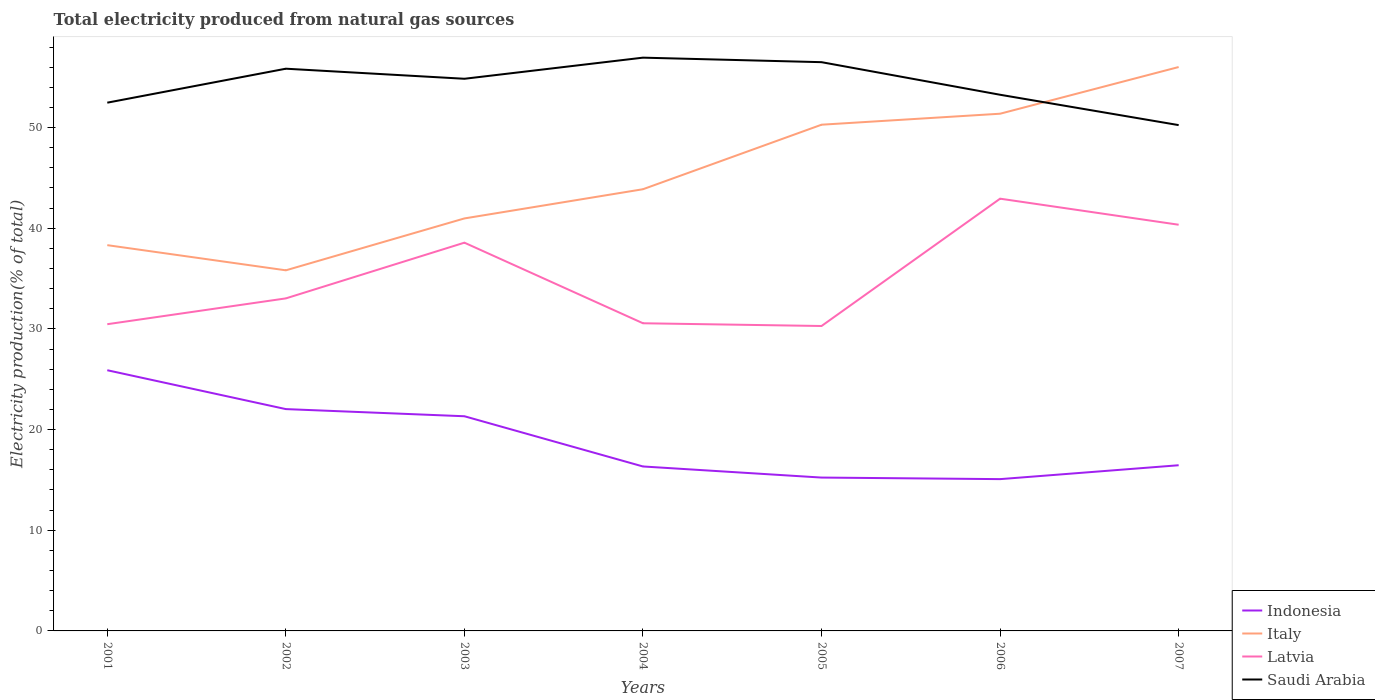Across all years, what is the maximum total electricity produced in Italy?
Give a very brief answer. 35.82. What is the total total electricity produced in Italy in the graph?
Keep it short and to the point. -17.69. What is the difference between the highest and the second highest total electricity produced in Indonesia?
Your answer should be compact. 10.82. What is the difference between the highest and the lowest total electricity produced in Latvia?
Offer a terse response. 3. What is the difference between two consecutive major ticks on the Y-axis?
Give a very brief answer. 10. Are the values on the major ticks of Y-axis written in scientific E-notation?
Provide a succinct answer. No. Does the graph contain any zero values?
Your answer should be compact. No. Where does the legend appear in the graph?
Provide a short and direct response. Bottom right. How many legend labels are there?
Your answer should be compact. 4. How are the legend labels stacked?
Give a very brief answer. Vertical. What is the title of the graph?
Provide a short and direct response. Total electricity produced from natural gas sources. Does "Bahamas" appear as one of the legend labels in the graph?
Offer a terse response. No. What is the label or title of the X-axis?
Offer a terse response. Years. What is the label or title of the Y-axis?
Offer a very short reply. Electricity production(% of total). What is the Electricity production(% of total) of Indonesia in 2001?
Your answer should be compact. 25.9. What is the Electricity production(% of total) of Italy in 2001?
Give a very brief answer. 38.32. What is the Electricity production(% of total) in Latvia in 2001?
Provide a succinct answer. 30.47. What is the Electricity production(% of total) in Saudi Arabia in 2001?
Give a very brief answer. 52.47. What is the Electricity production(% of total) of Indonesia in 2002?
Your answer should be compact. 22.03. What is the Electricity production(% of total) in Italy in 2002?
Offer a very short reply. 35.82. What is the Electricity production(% of total) in Latvia in 2002?
Give a very brief answer. 33.03. What is the Electricity production(% of total) of Saudi Arabia in 2002?
Your answer should be very brief. 55.85. What is the Electricity production(% of total) in Indonesia in 2003?
Your response must be concise. 21.32. What is the Electricity production(% of total) in Italy in 2003?
Offer a terse response. 40.97. What is the Electricity production(% of total) of Latvia in 2003?
Give a very brief answer. 38.57. What is the Electricity production(% of total) in Saudi Arabia in 2003?
Offer a very short reply. 54.85. What is the Electricity production(% of total) in Indonesia in 2004?
Your answer should be compact. 16.34. What is the Electricity production(% of total) in Italy in 2004?
Offer a very short reply. 43.87. What is the Electricity production(% of total) in Latvia in 2004?
Offer a very short reply. 30.56. What is the Electricity production(% of total) in Saudi Arabia in 2004?
Provide a short and direct response. 56.95. What is the Electricity production(% of total) in Indonesia in 2005?
Ensure brevity in your answer.  15.23. What is the Electricity production(% of total) of Italy in 2005?
Provide a succinct answer. 50.28. What is the Electricity production(% of total) in Latvia in 2005?
Make the answer very short. 30.29. What is the Electricity production(% of total) of Saudi Arabia in 2005?
Provide a succinct answer. 56.5. What is the Electricity production(% of total) in Indonesia in 2006?
Offer a terse response. 15.08. What is the Electricity production(% of total) in Italy in 2006?
Provide a short and direct response. 51.38. What is the Electricity production(% of total) of Latvia in 2006?
Provide a short and direct response. 42.94. What is the Electricity production(% of total) in Saudi Arabia in 2006?
Provide a short and direct response. 53.26. What is the Electricity production(% of total) of Indonesia in 2007?
Your answer should be compact. 16.46. What is the Electricity production(% of total) of Italy in 2007?
Ensure brevity in your answer.  56.01. What is the Electricity production(% of total) of Latvia in 2007?
Your answer should be very brief. 40.35. What is the Electricity production(% of total) of Saudi Arabia in 2007?
Provide a succinct answer. 50.24. Across all years, what is the maximum Electricity production(% of total) of Indonesia?
Offer a very short reply. 25.9. Across all years, what is the maximum Electricity production(% of total) of Italy?
Your answer should be compact. 56.01. Across all years, what is the maximum Electricity production(% of total) in Latvia?
Give a very brief answer. 42.94. Across all years, what is the maximum Electricity production(% of total) in Saudi Arabia?
Provide a short and direct response. 56.95. Across all years, what is the minimum Electricity production(% of total) of Indonesia?
Your response must be concise. 15.08. Across all years, what is the minimum Electricity production(% of total) of Italy?
Ensure brevity in your answer.  35.82. Across all years, what is the minimum Electricity production(% of total) in Latvia?
Make the answer very short. 30.29. Across all years, what is the minimum Electricity production(% of total) of Saudi Arabia?
Your answer should be very brief. 50.24. What is the total Electricity production(% of total) of Indonesia in the graph?
Provide a succinct answer. 132.36. What is the total Electricity production(% of total) of Italy in the graph?
Offer a terse response. 316.66. What is the total Electricity production(% of total) in Latvia in the graph?
Offer a very short reply. 246.2. What is the total Electricity production(% of total) of Saudi Arabia in the graph?
Your answer should be very brief. 380.11. What is the difference between the Electricity production(% of total) in Indonesia in 2001 and that in 2002?
Your answer should be very brief. 3.86. What is the difference between the Electricity production(% of total) of Italy in 2001 and that in 2002?
Provide a short and direct response. 2.5. What is the difference between the Electricity production(% of total) in Latvia in 2001 and that in 2002?
Your answer should be very brief. -2.56. What is the difference between the Electricity production(% of total) of Saudi Arabia in 2001 and that in 2002?
Your response must be concise. -3.37. What is the difference between the Electricity production(% of total) in Indonesia in 2001 and that in 2003?
Provide a short and direct response. 4.57. What is the difference between the Electricity production(% of total) in Italy in 2001 and that in 2003?
Make the answer very short. -2.65. What is the difference between the Electricity production(% of total) of Latvia in 2001 and that in 2003?
Your answer should be compact. -8.1. What is the difference between the Electricity production(% of total) of Saudi Arabia in 2001 and that in 2003?
Offer a very short reply. -2.37. What is the difference between the Electricity production(% of total) in Indonesia in 2001 and that in 2004?
Give a very brief answer. 9.56. What is the difference between the Electricity production(% of total) of Italy in 2001 and that in 2004?
Give a very brief answer. -5.56. What is the difference between the Electricity production(% of total) in Latvia in 2001 and that in 2004?
Offer a terse response. -0.09. What is the difference between the Electricity production(% of total) in Saudi Arabia in 2001 and that in 2004?
Ensure brevity in your answer.  -4.47. What is the difference between the Electricity production(% of total) in Indonesia in 2001 and that in 2005?
Offer a very short reply. 10.66. What is the difference between the Electricity production(% of total) in Italy in 2001 and that in 2005?
Keep it short and to the point. -11.96. What is the difference between the Electricity production(% of total) in Latvia in 2001 and that in 2005?
Your answer should be compact. 0.18. What is the difference between the Electricity production(% of total) of Saudi Arabia in 2001 and that in 2005?
Make the answer very short. -4.02. What is the difference between the Electricity production(% of total) of Indonesia in 2001 and that in 2006?
Ensure brevity in your answer.  10.82. What is the difference between the Electricity production(% of total) in Italy in 2001 and that in 2006?
Provide a succinct answer. -13.06. What is the difference between the Electricity production(% of total) of Latvia in 2001 and that in 2006?
Provide a short and direct response. -12.47. What is the difference between the Electricity production(% of total) of Saudi Arabia in 2001 and that in 2006?
Your answer should be compact. -0.79. What is the difference between the Electricity production(% of total) of Indonesia in 2001 and that in 2007?
Your answer should be very brief. 9.44. What is the difference between the Electricity production(% of total) in Italy in 2001 and that in 2007?
Keep it short and to the point. -17.69. What is the difference between the Electricity production(% of total) in Latvia in 2001 and that in 2007?
Your answer should be very brief. -9.88. What is the difference between the Electricity production(% of total) in Saudi Arabia in 2001 and that in 2007?
Provide a short and direct response. 2.23. What is the difference between the Electricity production(% of total) in Indonesia in 2002 and that in 2003?
Your response must be concise. 0.71. What is the difference between the Electricity production(% of total) in Italy in 2002 and that in 2003?
Keep it short and to the point. -5.15. What is the difference between the Electricity production(% of total) of Latvia in 2002 and that in 2003?
Provide a short and direct response. -5.53. What is the difference between the Electricity production(% of total) in Saudi Arabia in 2002 and that in 2003?
Offer a very short reply. 1. What is the difference between the Electricity production(% of total) in Indonesia in 2002 and that in 2004?
Give a very brief answer. 5.7. What is the difference between the Electricity production(% of total) of Italy in 2002 and that in 2004?
Offer a very short reply. -8.05. What is the difference between the Electricity production(% of total) of Latvia in 2002 and that in 2004?
Ensure brevity in your answer.  2.47. What is the difference between the Electricity production(% of total) of Saudi Arabia in 2002 and that in 2004?
Give a very brief answer. -1.1. What is the difference between the Electricity production(% of total) of Indonesia in 2002 and that in 2005?
Give a very brief answer. 6.8. What is the difference between the Electricity production(% of total) of Italy in 2002 and that in 2005?
Offer a very short reply. -14.46. What is the difference between the Electricity production(% of total) in Latvia in 2002 and that in 2005?
Provide a short and direct response. 2.74. What is the difference between the Electricity production(% of total) of Saudi Arabia in 2002 and that in 2005?
Ensure brevity in your answer.  -0.65. What is the difference between the Electricity production(% of total) of Indonesia in 2002 and that in 2006?
Offer a terse response. 6.96. What is the difference between the Electricity production(% of total) of Italy in 2002 and that in 2006?
Keep it short and to the point. -15.56. What is the difference between the Electricity production(% of total) in Latvia in 2002 and that in 2006?
Your answer should be very brief. -9.9. What is the difference between the Electricity production(% of total) in Saudi Arabia in 2002 and that in 2006?
Your answer should be very brief. 2.59. What is the difference between the Electricity production(% of total) in Indonesia in 2002 and that in 2007?
Give a very brief answer. 5.58. What is the difference between the Electricity production(% of total) in Italy in 2002 and that in 2007?
Keep it short and to the point. -20.19. What is the difference between the Electricity production(% of total) of Latvia in 2002 and that in 2007?
Keep it short and to the point. -7.32. What is the difference between the Electricity production(% of total) in Saudi Arabia in 2002 and that in 2007?
Offer a terse response. 5.6. What is the difference between the Electricity production(% of total) of Indonesia in 2003 and that in 2004?
Keep it short and to the point. 4.99. What is the difference between the Electricity production(% of total) of Italy in 2003 and that in 2004?
Give a very brief answer. -2.9. What is the difference between the Electricity production(% of total) of Latvia in 2003 and that in 2004?
Keep it short and to the point. 8.01. What is the difference between the Electricity production(% of total) in Saudi Arabia in 2003 and that in 2004?
Your answer should be compact. -2.1. What is the difference between the Electricity production(% of total) of Indonesia in 2003 and that in 2005?
Make the answer very short. 6.09. What is the difference between the Electricity production(% of total) of Italy in 2003 and that in 2005?
Offer a very short reply. -9.31. What is the difference between the Electricity production(% of total) in Latvia in 2003 and that in 2005?
Your response must be concise. 8.28. What is the difference between the Electricity production(% of total) in Saudi Arabia in 2003 and that in 2005?
Your response must be concise. -1.65. What is the difference between the Electricity production(% of total) in Indonesia in 2003 and that in 2006?
Your answer should be compact. 6.25. What is the difference between the Electricity production(% of total) in Italy in 2003 and that in 2006?
Make the answer very short. -10.4. What is the difference between the Electricity production(% of total) of Latvia in 2003 and that in 2006?
Make the answer very short. -4.37. What is the difference between the Electricity production(% of total) in Saudi Arabia in 2003 and that in 2006?
Your answer should be compact. 1.59. What is the difference between the Electricity production(% of total) in Indonesia in 2003 and that in 2007?
Offer a very short reply. 4.87. What is the difference between the Electricity production(% of total) of Italy in 2003 and that in 2007?
Make the answer very short. -15.04. What is the difference between the Electricity production(% of total) in Latvia in 2003 and that in 2007?
Provide a succinct answer. -1.78. What is the difference between the Electricity production(% of total) in Saudi Arabia in 2003 and that in 2007?
Your answer should be very brief. 4.6. What is the difference between the Electricity production(% of total) in Indonesia in 2004 and that in 2005?
Give a very brief answer. 1.1. What is the difference between the Electricity production(% of total) in Italy in 2004 and that in 2005?
Ensure brevity in your answer.  -6.41. What is the difference between the Electricity production(% of total) of Latvia in 2004 and that in 2005?
Your answer should be compact. 0.27. What is the difference between the Electricity production(% of total) in Saudi Arabia in 2004 and that in 2005?
Offer a very short reply. 0.45. What is the difference between the Electricity production(% of total) of Indonesia in 2004 and that in 2006?
Your response must be concise. 1.26. What is the difference between the Electricity production(% of total) of Italy in 2004 and that in 2006?
Your answer should be compact. -7.5. What is the difference between the Electricity production(% of total) in Latvia in 2004 and that in 2006?
Make the answer very short. -12.38. What is the difference between the Electricity production(% of total) of Saudi Arabia in 2004 and that in 2006?
Your answer should be compact. 3.69. What is the difference between the Electricity production(% of total) in Indonesia in 2004 and that in 2007?
Provide a succinct answer. -0.12. What is the difference between the Electricity production(% of total) in Italy in 2004 and that in 2007?
Ensure brevity in your answer.  -12.14. What is the difference between the Electricity production(% of total) of Latvia in 2004 and that in 2007?
Your response must be concise. -9.79. What is the difference between the Electricity production(% of total) of Saudi Arabia in 2004 and that in 2007?
Make the answer very short. 6.7. What is the difference between the Electricity production(% of total) of Indonesia in 2005 and that in 2006?
Make the answer very short. 0.16. What is the difference between the Electricity production(% of total) in Italy in 2005 and that in 2006?
Provide a short and direct response. -1.09. What is the difference between the Electricity production(% of total) of Latvia in 2005 and that in 2006?
Offer a very short reply. -12.65. What is the difference between the Electricity production(% of total) of Saudi Arabia in 2005 and that in 2006?
Keep it short and to the point. 3.24. What is the difference between the Electricity production(% of total) of Indonesia in 2005 and that in 2007?
Give a very brief answer. -1.22. What is the difference between the Electricity production(% of total) of Italy in 2005 and that in 2007?
Keep it short and to the point. -5.73. What is the difference between the Electricity production(% of total) in Latvia in 2005 and that in 2007?
Provide a short and direct response. -10.06. What is the difference between the Electricity production(% of total) of Saudi Arabia in 2005 and that in 2007?
Keep it short and to the point. 6.25. What is the difference between the Electricity production(% of total) in Indonesia in 2006 and that in 2007?
Your answer should be very brief. -1.38. What is the difference between the Electricity production(% of total) in Italy in 2006 and that in 2007?
Your answer should be compact. -4.64. What is the difference between the Electricity production(% of total) in Latvia in 2006 and that in 2007?
Offer a terse response. 2.59. What is the difference between the Electricity production(% of total) in Saudi Arabia in 2006 and that in 2007?
Your response must be concise. 3.02. What is the difference between the Electricity production(% of total) of Indonesia in 2001 and the Electricity production(% of total) of Italy in 2002?
Make the answer very short. -9.93. What is the difference between the Electricity production(% of total) in Indonesia in 2001 and the Electricity production(% of total) in Latvia in 2002?
Keep it short and to the point. -7.14. What is the difference between the Electricity production(% of total) in Indonesia in 2001 and the Electricity production(% of total) in Saudi Arabia in 2002?
Provide a succinct answer. -29.95. What is the difference between the Electricity production(% of total) of Italy in 2001 and the Electricity production(% of total) of Latvia in 2002?
Offer a very short reply. 5.29. What is the difference between the Electricity production(% of total) of Italy in 2001 and the Electricity production(% of total) of Saudi Arabia in 2002?
Ensure brevity in your answer.  -17.53. What is the difference between the Electricity production(% of total) of Latvia in 2001 and the Electricity production(% of total) of Saudi Arabia in 2002?
Provide a short and direct response. -25.38. What is the difference between the Electricity production(% of total) in Indonesia in 2001 and the Electricity production(% of total) in Italy in 2003?
Offer a very short reply. -15.08. What is the difference between the Electricity production(% of total) of Indonesia in 2001 and the Electricity production(% of total) of Latvia in 2003?
Provide a succinct answer. -12.67. What is the difference between the Electricity production(% of total) of Indonesia in 2001 and the Electricity production(% of total) of Saudi Arabia in 2003?
Your response must be concise. -28.95. What is the difference between the Electricity production(% of total) in Italy in 2001 and the Electricity production(% of total) in Latvia in 2003?
Your response must be concise. -0.25. What is the difference between the Electricity production(% of total) in Italy in 2001 and the Electricity production(% of total) in Saudi Arabia in 2003?
Make the answer very short. -16.53. What is the difference between the Electricity production(% of total) in Latvia in 2001 and the Electricity production(% of total) in Saudi Arabia in 2003?
Provide a short and direct response. -24.38. What is the difference between the Electricity production(% of total) in Indonesia in 2001 and the Electricity production(% of total) in Italy in 2004?
Your answer should be compact. -17.98. What is the difference between the Electricity production(% of total) in Indonesia in 2001 and the Electricity production(% of total) in Latvia in 2004?
Provide a succinct answer. -4.67. What is the difference between the Electricity production(% of total) of Indonesia in 2001 and the Electricity production(% of total) of Saudi Arabia in 2004?
Your response must be concise. -31.05. What is the difference between the Electricity production(% of total) of Italy in 2001 and the Electricity production(% of total) of Latvia in 2004?
Provide a succinct answer. 7.76. What is the difference between the Electricity production(% of total) in Italy in 2001 and the Electricity production(% of total) in Saudi Arabia in 2004?
Your answer should be compact. -18.63. What is the difference between the Electricity production(% of total) of Latvia in 2001 and the Electricity production(% of total) of Saudi Arabia in 2004?
Provide a short and direct response. -26.48. What is the difference between the Electricity production(% of total) of Indonesia in 2001 and the Electricity production(% of total) of Italy in 2005?
Provide a short and direct response. -24.39. What is the difference between the Electricity production(% of total) in Indonesia in 2001 and the Electricity production(% of total) in Latvia in 2005?
Keep it short and to the point. -4.39. What is the difference between the Electricity production(% of total) in Indonesia in 2001 and the Electricity production(% of total) in Saudi Arabia in 2005?
Your answer should be compact. -30.6. What is the difference between the Electricity production(% of total) in Italy in 2001 and the Electricity production(% of total) in Latvia in 2005?
Keep it short and to the point. 8.03. What is the difference between the Electricity production(% of total) of Italy in 2001 and the Electricity production(% of total) of Saudi Arabia in 2005?
Keep it short and to the point. -18.18. What is the difference between the Electricity production(% of total) of Latvia in 2001 and the Electricity production(% of total) of Saudi Arabia in 2005?
Provide a short and direct response. -26.03. What is the difference between the Electricity production(% of total) in Indonesia in 2001 and the Electricity production(% of total) in Italy in 2006?
Give a very brief answer. -25.48. What is the difference between the Electricity production(% of total) in Indonesia in 2001 and the Electricity production(% of total) in Latvia in 2006?
Provide a succinct answer. -17.04. What is the difference between the Electricity production(% of total) of Indonesia in 2001 and the Electricity production(% of total) of Saudi Arabia in 2006?
Keep it short and to the point. -27.36. What is the difference between the Electricity production(% of total) of Italy in 2001 and the Electricity production(% of total) of Latvia in 2006?
Make the answer very short. -4.62. What is the difference between the Electricity production(% of total) in Italy in 2001 and the Electricity production(% of total) in Saudi Arabia in 2006?
Ensure brevity in your answer.  -14.94. What is the difference between the Electricity production(% of total) in Latvia in 2001 and the Electricity production(% of total) in Saudi Arabia in 2006?
Offer a very short reply. -22.79. What is the difference between the Electricity production(% of total) in Indonesia in 2001 and the Electricity production(% of total) in Italy in 2007?
Ensure brevity in your answer.  -30.12. What is the difference between the Electricity production(% of total) in Indonesia in 2001 and the Electricity production(% of total) in Latvia in 2007?
Your answer should be very brief. -14.45. What is the difference between the Electricity production(% of total) in Indonesia in 2001 and the Electricity production(% of total) in Saudi Arabia in 2007?
Ensure brevity in your answer.  -24.35. What is the difference between the Electricity production(% of total) in Italy in 2001 and the Electricity production(% of total) in Latvia in 2007?
Make the answer very short. -2.03. What is the difference between the Electricity production(% of total) in Italy in 2001 and the Electricity production(% of total) in Saudi Arabia in 2007?
Your response must be concise. -11.92. What is the difference between the Electricity production(% of total) of Latvia in 2001 and the Electricity production(% of total) of Saudi Arabia in 2007?
Offer a very short reply. -19.78. What is the difference between the Electricity production(% of total) in Indonesia in 2002 and the Electricity production(% of total) in Italy in 2003?
Make the answer very short. -18.94. What is the difference between the Electricity production(% of total) of Indonesia in 2002 and the Electricity production(% of total) of Latvia in 2003?
Provide a short and direct response. -16.53. What is the difference between the Electricity production(% of total) in Indonesia in 2002 and the Electricity production(% of total) in Saudi Arabia in 2003?
Give a very brief answer. -32.81. What is the difference between the Electricity production(% of total) in Italy in 2002 and the Electricity production(% of total) in Latvia in 2003?
Keep it short and to the point. -2.75. What is the difference between the Electricity production(% of total) of Italy in 2002 and the Electricity production(% of total) of Saudi Arabia in 2003?
Keep it short and to the point. -19.03. What is the difference between the Electricity production(% of total) in Latvia in 2002 and the Electricity production(% of total) in Saudi Arabia in 2003?
Keep it short and to the point. -21.82. What is the difference between the Electricity production(% of total) of Indonesia in 2002 and the Electricity production(% of total) of Italy in 2004?
Give a very brief answer. -21.84. What is the difference between the Electricity production(% of total) of Indonesia in 2002 and the Electricity production(% of total) of Latvia in 2004?
Your response must be concise. -8.53. What is the difference between the Electricity production(% of total) in Indonesia in 2002 and the Electricity production(% of total) in Saudi Arabia in 2004?
Your answer should be compact. -34.91. What is the difference between the Electricity production(% of total) of Italy in 2002 and the Electricity production(% of total) of Latvia in 2004?
Your answer should be compact. 5.26. What is the difference between the Electricity production(% of total) of Italy in 2002 and the Electricity production(% of total) of Saudi Arabia in 2004?
Your answer should be very brief. -21.12. What is the difference between the Electricity production(% of total) of Latvia in 2002 and the Electricity production(% of total) of Saudi Arabia in 2004?
Your response must be concise. -23.91. What is the difference between the Electricity production(% of total) of Indonesia in 2002 and the Electricity production(% of total) of Italy in 2005?
Offer a terse response. -28.25. What is the difference between the Electricity production(% of total) in Indonesia in 2002 and the Electricity production(% of total) in Latvia in 2005?
Ensure brevity in your answer.  -8.26. What is the difference between the Electricity production(% of total) in Indonesia in 2002 and the Electricity production(% of total) in Saudi Arabia in 2005?
Your answer should be very brief. -34.46. What is the difference between the Electricity production(% of total) of Italy in 2002 and the Electricity production(% of total) of Latvia in 2005?
Your response must be concise. 5.53. What is the difference between the Electricity production(% of total) in Italy in 2002 and the Electricity production(% of total) in Saudi Arabia in 2005?
Offer a terse response. -20.68. What is the difference between the Electricity production(% of total) of Latvia in 2002 and the Electricity production(% of total) of Saudi Arabia in 2005?
Provide a succinct answer. -23.46. What is the difference between the Electricity production(% of total) of Indonesia in 2002 and the Electricity production(% of total) of Italy in 2006?
Your response must be concise. -29.34. What is the difference between the Electricity production(% of total) in Indonesia in 2002 and the Electricity production(% of total) in Latvia in 2006?
Your answer should be compact. -20.9. What is the difference between the Electricity production(% of total) in Indonesia in 2002 and the Electricity production(% of total) in Saudi Arabia in 2006?
Provide a short and direct response. -31.22. What is the difference between the Electricity production(% of total) in Italy in 2002 and the Electricity production(% of total) in Latvia in 2006?
Offer a very short reply. -7.12. What is the difference between the Electricity production(% of total) of Italy in 2002 and the Electricity production(% of total) of Saudi Arabia in 2006?
Your answer should be very brief. -17.44. What is the difference between the Electricity production(% of total) in Latvia in 2002 and the Electricity production(% of total) in Saudi Arabia in 2006?
Your answer should be compact. -20.23. What is the difference between the Electricity production(% of total) of Indonesia in 2002 and the Electricity production(% of total) of Italy in 2007?
Provide a succinct answer. -33.98. What is the difference between the Electricity production(% of total) in Indonesia in 2002 and the Electricity production(% of total) in Latvia in 2007?
Make the answer very short. -18.31. What is the difference between the Electricity production(% of total) in Indonesia in 2002 and the Electricity production(% of total) in Saudi Arabia in 2007?
Give a very brief answer. -28.21. What is the difference between the Electricity production(% of total) of Italy in 2002 and the Electricity production(% of total) of Latvia in 2007?
Ensure brevity in your answer.  -4.53. What is the difference between the Electricity production(% of total) in Italy in 2002 and the Electricity production(% of total) in Saudi Arabia in 2007?
Your answer should be compact. -14.42. What is the difference between the Electricity production(% of total) of Latvia in 2002 and the Electricity production(% of total) of Saudi Arabia in 2007?
Your answer should be compact. -17.21. What is the difference between the Electricity production(% of total) of Indonesia in 2003 and the Electricity production(% of total) of Italy in 2004?
Offer a very short reply. -22.55. What is the difference between the Electricity production(% of total) in Indonesia in 2003 and the Electricity production(% of total) in Latvia in 2004?
Ensure brevity in your answer.  -9.24. What is the difference between the Electricity production(% of total) of Indonesia in 2003 and the Electricity production(% of total) of Saudi Arabia in 2004?
Make the answer very short. -35.62. What is the difference between the Electricity production(% of total) in Italy in 2003 and the Electricity production(% of total) in Latvia in 2004?
Your response must be concise. 10.41. What is the difference between the Electricity production(% of total) of Italy in 2003 and the Electricity production(% of total) of Saudi Arabia in 2004?
Offer a terse response. -15.97. What is the difference between the Electricity production(% of total) in Latvia in 2003 and the Electricity production(% of total) in Saudi Arabia in 2004?
Keep it short and to the point. -18.38. What is the difference between the Electricity production(% of total) in Indonesia in 2003 and the Electricity production(% of total) in Italy in 2005?
Ensure brevity in your answer.  -28.96. What is the difference between the Electricity production(% of total) of Indonesia in 2003 and the Electricity production(% of total) of Latvia in 2005?
Make the answer very short. -8.97. What is the difference between the Electricity production(% of total) of Indonesia in 2003 and the Electricity production(% of total) of Saudi Arabia in 2005?
Your response must be concise. -35.17. What is the difference between the Electricity production(% of total) in Italy in 2003 and the Electricity production(% of total) in Latvia in 2005?
Offer a terse response. 10.68. What is the difference between the Electricity production(% of total) in Italy in 2003 and the Electricity production(% of total) in Saudi Arabia in 2005?
Offer a terse response. -15.52. What is the difference between the Electricity production(% of total) in Latvia in 2003 and the Electricity production(% of total) in Saudi Arabia in 2005?
Provide a succinct answer. -17.93. What is the difference between the Electricity production(% of total) of Indonesia in 2003 and the Electricity production(% of total) of Italy in 2006?
Provide a succinct answer. -30.05. What is the difference between the Electricity production(% of total) of Indonesia in 2003 and the Electricity production(% of total) of Latvia in 2006?
Provide a short and direct response. -21.61. What is the difference between the Electricity production(% of total) in Indonesia in 2003 and the Electricity production(% of total) in Saudi Arabia in 2006?
Your response must be concise. -31.93. What is the difference between the Electricity production(% of total) of Italy in 2003 and the Electricity production(% of total) of Latvia in 2006?
Your response must be concise. -1.96. What is the difference between the Electricity production(% of total) in Italy in 2003 and the Electricity production(% of total) in Saudi Arabia in 2006?
Keep it short and to the point. -12.28. What is the difference between the Electricity production(% of total) in Latvia in 2003 and the Electricity production(% of total) in Saudi Arabia in 2006?
Offer a very short reply. -14.69. What is the difference between the Electricity production(% of total) of Indonesia in 2003 and the Electricity production(% of total) of Italy in 2007?
Provide a succinct answer. -34.69. What is the difference between the Electricity production(% of total) of Indonesia in 2003 and the Electricity production(% of total) of Latvia in 2007?
Give a very brief answer. -19.02. What is the difference between the Electricity production(% of total) in Indonesia in 2003 and the Electricity production(% of total) in Saudi Arabia in 2007?
Ensure brevity in your answer.  -28.92. What is the difference between the Electricity production(% of total) of Italy in 2003 and the Electricity production(% of total) of Latvia in 2007?
Offer a very short reply. 0.63. What is the difference between the Electricity production(% of total) of Italy in 2003 and the Electricity production(% of total) of Saudi Arabia in 2007?
Offer a terse response. -9.27. What is the difference between the Electricity production(% of total) in Latvia in 2003 and the Electricity production(% of total) in Saudi Arabia in 2007?
Your answer should be compact. -11.68. What is the difference between the Electricity production(% of total) in Indonesia in 2004 and the Electricity production(% of total) in Italy in 2005?
Ensure brevity in your answer.  -33.95. What is the difference between the Electricity production(% of total) of Indonesia in 2004 and the Electricity production(% of total) of Latvia in 2005?
Offer a terse response. -13.95. What is the difference between the Electricity production(% of total) of Indonesia in 2004 and the Electricity production(% of total) of Saudi Arabia in 2005?
Provide a succinct answer. -40.16. What is the difference between the Electricity production(% of total) of Italy in 2004 and the Electricity production(% of total) of Latvia in 2005?
Provide a short and direct response. 13.59. What is the difference between the Electricity production(% of total) in Italy in 2004 and the Electricity production(% of total) in Saudi Arabia in 2005?
Give a very brief answer. -12.62. What is the difference between the Electricity production(% of total) of Latvia in 2004 and the Electricity production(% of total) of Saudi Arabia in 2005?
Your answer should be compact. -25.94. What is the difference between the Electricity production(% of total) in Indonesia in 2004 and the Electricity production(% of total) in Italy in 2006?
Your answer should be compact. -35.04. What is the difference between the Electricity production(% of total) of Indonesia in 2004 and the Electricity production(% of total) of Latvia in 2006?
Your answer should be compact. -26.6. What is the difference between the Electricity production(% of total) of Indonesia in 2004 and the Electricity production(% of total) of Saudi Arabia in 2006?
Keep it short and to the point. -36.92. What is the difference between the Electricity production(% of total) of Italy in 2004 and the Electricity production(% of total) of Latvia in 2006?
Keep it short and to the point. 0.94. What is the difference between the Electricity production(% of total) of Italy in 2004 and the Electricity production(% of total) of Saudi Arabia in 2006?
Make the answer very short. -9.38. What is the difference between the Electricity production(% of total) in Latvia in 2004 and the Electricity production(% of total) in Saudi Arabia in 2006?
Offer a very short reply. -22.7. What is the difference between the Electricity production(% of total) in Indonesia in 2004 and the Electricity production(% of total) in Italy in 2007?
Your answer should be very brief. -39.68. What is the difference between the Electricity production(% of total) of Indonesia in 2004 and the Electricity production(% of total) of Latvia in 2007?
Your response must be concise. -24.01. What is the difference between the Electricity production(% of total) in Indonesia in 2004 and the Electricity production(% of total) in Saudi Arabia in 2007?
Offer a terse response. -33.91. What is the difference between the Electricity production(% of total) in Italy in 2004 and the Electricity production(% of total) in Latvia in 2007?
Give a very brief answer. 3.53. What is the difference between the Electricity production(% of total) in Italy in 2004 and the Electricity production(% of total) in Saudi Arabia in 2007?
Give a very brief answer. -6.37. What is the difference between the Electricity production(% of total) of Latvia in 2004 and the Electricity production(% of total) of Saudi Arabia in 2007?
Keep it short and to the point. -19.68. What is the difference between the Electricity production(% of total) of Indonesia in 2005 and the Electricity production(% of total) of Italy in 2006?
Make the answer very short. -36.14. What is the difference between the Electricity production(% of total) of Indonesia in 2005 and the Electricity production(% of total) of Latvia in 2006?
Your response must be concise. -27.7. What is the difference between the Electricity production(% of total) of Indonesia in 2005 and the Electricity production(% of total) of Saudi Arabia in 2006?
Ensure brevity in your answer.  -38.03. What is the difference between the Electricity production(% of total) of Italy in 2005 and the Electricity production(% of total) of Latvia in 2006?
Offer a very short reply. 7.35. What is the difference between the Electricity production(% of total) in Italy in 2005 and the Electricity production(% of total) in Saudi Arabia in 2006?
Your answer should be very brief. -2.98. What is the difference between the Electricity production(% of total) in Latvia in 2005 and the Electricity production(% of total) in Saudi Arabia in 2006?
Provide a succinct answer. -22.97. What is the difference between the Electricity production(% of total) of Indonesia in 2005 and the Electricity production(% of total) of Italy in 2007?
Your answer should be very brief. -40.78. What is the difference between the Electricity production(% of total) of Indonesia in 2005 and the Electricity production(% of total) of Latvia in 2007?
Your answer should be very brief. -25.11. What is the difference between the Electricity production(% of total) in Indonesia in 2005 and the Electricity production(% of total) in Saudi Arabia in 2007?
Make the answer very short. -35.01. What is the difference between the Electricity production(% of total) of Italy in 2005 and the Electricity production(% of total) of Latvia in 2007?
Make the answer very short. 9.94. What is the difference between the Electricity production(% of total) in Italy in 2005 and the Electricity production(% of total) in Saudi Arabia in 2007?
Offer a very short reply. 0.04. What is the difference between the Electricity production(% of total) in Latvia in 2005 and the Electricity production(% of total) in Saudi Arabia in 2007?
Provide a succinct answer. -19.95. What is the difference between the Electricity production(% of total) of Indonesia in 2006 and the Electricity production(% of total) of Italy in 2007?
Provide a succinct answer. -40.94. What is the difference between the Electricity production(% of total) of Indonesia in 2006 and the Electricity production(% of total) of Latvia in 2007?
Provide a short and direct response. -25.27. What is the difference between the Electricity production(% of total) in Indonesia in 2006 and the Electricity production(% of total) in Saudi Arabia in 2007?
Your response must be concise. -35.17. What is the difference between the Electricity production(% of total) in Italy in 2006 and the Electricity production(% of total) in Latvia in 2007?
Keep it short and to the point. 11.03. What is the difference between the Electricity production(% of total) of Italy in 2006 and the Electricity production(% of total) of Saudi Arabia in 2007?
Provide a succinct answer. 1.13. What is the difference between the Electricity production(% of total) in Latvia in 2006 and the Electricity production(% of total) in Saudi Arabia in 2007?
Provide a succinct answer. -7.31. What is the average Electricity production(% of total) of Indonesia per year?
Your answer should be very brief. 18.91. What is the average Electricity production(% of total) of Italy per year?
Ensure brevity in your answer.  45.24. What is the average Electricity production(% of total) of Latvia per year?
Offer a terse response. 35.17. What is the average Electricity production(% of total) of Saudi Arabia per year?
Make the answer very short. 54.3. In the year 2001, what is the difference between the Electricity production(% of total) of Indonesia and Electricity production(% of total) of Italy?
Offer a very short reply. -12.42. In the year 2001, what is the difference between the Electricity production(% of total) in Indonesia and Electricity production(% of total) in Latvia?
Give a very brief answer. -4.57. In the year 2001, what is the difference between the Electricity production(% of total) in Indonesia and Electricity production(% of total) in Saudi Arabia?
Your answer should be compact. -26.58. In the year 2001, what is the difference between the Electricity production(% of total) in Italy and Electricity production(% of total) in Latvia?
Provide a short and direct response. 7.85. In the year 2001, what is the difference between the Electricity production(% of total) of Italy and Electricity production(% of total) of Saudi Arabia?
Your answer should be very brief. -14.15. In the year 2001, what is the difference between the Electricity production(% of total) in Latvia and Electricity production(% of total) in Saudi Arabia?
Give a very brief answer. -22.01. In the year 2002, what is the difference between the Electricity production(% of total) in Indonesia and Electricity production(% of total) in Italy?
Give a very brief answer. -13.79. In the year 2002, what is the difference between the Electricity production(% of total) of Indonesia and Electricity production(% of total) of Latvia?
Your answer should be compact. -11. In the year 2002, what is the difference between the Electricity production(% of total) of Indonesia and Electricity production(% of total) of Saudi Arabia?
Your answer should be very brief. -33.81. In the year 2002, what is the difference between the Electricity production(% of total) in Italy and Electricity production(% of total) in Latvia?
Offer a very short reply. 2.79. In the year 2002, what is the difference between the Electricity production(% of total) of Italy and Electricity production(% of total) of Saudi Arabia?
Your answer should be compact. -20.03. In the year 2002, what is the difference between the Electricity production(% of total) in Latvia and Electricity production(% of total) in Saudi Arabia?
Your answer should be very brief. -22.82. In the year 2003, what is the difference between the Electricity production(% of total) in Indonesia and Electricity production(% of total) in Italy?
Give a very brief answer. -19.65. In the year 2003, what is the difference between the Electricity production(% of total) of Indonesia and Electricity production(% of total) of Latvia?
Provide a short and direct response. -17.24. In the year 2003, what is the difference between the Electricity production(% of total) of Indonesia and Electricity production(% of total) of Saudi Arabia?
Your response must be concise. -33.52. In the year 2003, what is the difference between the Electricity production(% of total) of Italy and Electricity production(% of total) of Latvia?
Provide a succinct answer. 2.41. In the year 2003, what is the difference between the Electricity production(% of total) in Italy and Electricity production(% of total) in Saudi Arabia?
Provide a short and direct response. -13.87. In the year 2003, what is the difference between the Electricity production(% of total) of Latvia and Electricity production(% of total) of Saudi Arabia?
Your answer should be compact. -16.28. In the year 2004, what is the difference between the Electricity production(% of total) in Indonesia and Electricity production(% of total) in Italy?
Provide a short and direct response. -27.54. In the year 2004, what is the difference between the Electricity production(% of total) of Indonesia and Electricity production(% of total) of Latvia?
Ensure brevity in your answer.  -14.23. In the year 2004, what is the difference between the Electricity production(% of total) in Indonesia and Electricity production(% of total) in Saudi Arabia?
Provide a short and direct response. -40.61. In the year 2004, what is the difference between the Electricity production(% of total) in Italy and Electricity production(% of total) in Latvia?
Your answer should be compact. 13.31. In the year 2004, what is the difference between the Electricity production(% of total) of Italy and Electricity production(% of total) of Saudi Arabia?
Provide a succinct answer. -13.07. In the year 2004, what is the difference between the Electricity production(% of total) of Latvia and Electricity production(% of total) of Saudi Arabia?
Ensure brevity in your answer.  -26.38. In the year 2005, what is the difference between the Electricity production(% of total) of Indonesia and Electricity production(% of total) of Italy?
Your response must be concise. -35.05. In the year 2005, what is the difference between the Electricity production(% of total) of Indonesia and Electricity production(% of total) of Latvia?
Your response must be concise. -15.06. In the year 2005, what is the difference between the Electricity production(% of total) of Indonesia and Electricity production(% of total) of Saudi Arabia?
Provide a short and direct response. -41.26. In the year 2005, what is the difference between the Electricity production(% of total) in Italy and Electricity production(% of total) in Latvia?
Your answer should be very brief. 19.99. In the year 2005, what is the difference between the Electricity production(% of total) in Italy and Electricity production(% of total) in Saudi Arabia?
Make the answer very short. -6.21. In the year 2005, what is the difference between the Electricity production(% of total) of Latvia and Electricity production(% of total) of Saudi Arabia?
Offer a terse response. -26.21. In the year 2006, what is the difference between the Electricity production(% of total) of Indonesia and Electricity production(% of total) of Italy?
Ensure brevity in your answer.  -36.3. In the year 2006, what is the difference between the Electricity production(% of total) of Indonesia and Electricity production(% of total) of Latvia?
Keep it short and to the point. -27.86. In the year 2006, what is the difference between the Electricity production(% of total) of Indonesia and Electricity production(% of total) of Saudi Arabia?
Make the answer very short. -38.18. In the year 2006, what is the difference between the Electricity production(% of total) in Italy and Electricity production(% of total) in Latvia?
Offer a very short reply. 8.44. In the year 2006, what is the difference between the Electricity production(% of total) in Italy and Electricity production(% of total) in Saudi Arabia?
Offer a terse response. -1.88. In the year 2006, what is the difference between the Electricity production(% of total) in Latvia and Electricity production(% of total) in Saudi Arabia?
Your answer should be very brief. -10.32. In the year 2007, what is the difference between the Electricity production(% of total) in Indonesia and Electricity production(% of total) in Italy?
Provide a short and direct response. -39.56. In the year 2007, what is the difference between the Electricity production(% of total) in Indonesia and Electricity production(% of total) in Latvia?
Ensure brevity in your answer.  -23.89. In the year 2007, what is the difference between the Electricity production(% of total) in Indonesia and Electricity production(% of total) in Saudi Arabia?
Keep it short and to the point. -33.79. In the year 2007, what is the difference between the Electricity production(% of total) in Italy and Electricity production(% of total) in Latvia?
Your response must be concise. 15.67. In the year 2007, what is the difference between the Electricity production(% of total) of Italy and Electricity production(% of total) of Saudi Arabia?
Keep it short and to the point. 5.77. In the year 2007, what is the difference between the Electricity production(% of total) of Latvia and Electricity production(% of total) of Saudi Arabia?
Offer a terse response. -9.9. What is the ratio of the Electricity production(% of total) in Indonesia in 2001 to that in 2002?
Offer a very short reply. 1.18. What is the ratio of the Electricity production(% of total) of Italy in 2001 to that in 2002?
Give a very brief answer. 1.07. What is the ratio of the Electricity production(% of total) of Latvia in 2001 to that in 2002?
Your response must be concise. 0.92. What is the ratio of the Electricity production(% of total) of Saudi Arabia in 2001 to that in 2002?
Ensure brevity in your answer.  0.94. What is the ratio of the Electricity production(% of total) of Indonesia in 2001 to that in 2003?
Offer a very short reply. 1.21. What is the ratio of the Electricity production(% of total) of Italy in 2001 to that in 2003?
Provide a short and direct response. 0.94. What is the ratio of the Electricity production(% of total) in Latvia in 2001 to that in 2003?
Your response must be concise. 0.79. What is the ratio of the Electricity production(% of total) of Saudi Arabia in 2001 to that in 2003?
Provide a short and direct response. 0.96. What is the ratio of the Electricity production(% of total) of Indonesia in 2001 to that in 2004?
Give a very brief answer. 1.59. What is the ratio of the Electricity production(% of total) of Italy in 2001 to that in 2004?
Keep it short and to the point. 0.87. What is the ratio of the Electricity production(% of total) of Latvia in 2001 to that in 2004?
Make the answer very short. 1. What is the ratio of the Electricity production(% of total) in Saudi Arabia in 2001 to that in 2004?
Provide a succinct answer. 0.92. What is the ratio of the Electricity production(% of total) in Indonesia in 2001 to that in 2005?
Provide a succinct answer. 1.7. What is the ratio of the Electricity production(% of total) in Italy in 2001 to that in 2005?
Make the answer very short. 0.76. What is the ratio of the Electricity production(% of total) of Latvia in 2001 to that in 2005?
Ensure brevity in your answer.  1.01. What is the ratio of the Electricity production(% of total) in Saudi Arabia in 2001 to that in 2005?
Your answer should be very brief. 0.93. What is the ratio of the Electricity production(% of total) in Indonesia in 2001 to that in 2006?
Your answer should be very brief. 1.72. What is the ratio of the Electricity production(% of total) in Italy in 2001 to that in 2006?
Your answer should be very brief. 0.75. What is the ratio of the Electricity production(% of total) of Latvia in 2001 to that in 2006?
Make the answer very short. 0.71. What is the ratio of the Electricity production(% of total) in Saudi Arabia in 2001 to that in 2006?
Keep it short and to the point. 0.99. What is the ratio of the Electricity production(% of total) in Indonesia in 2001 to that in 2007?
Make the answer very short. 1.57. What is the ratio of the Electricity production(% of total) in Italy in 2001 to that in 2007?
Your response must be concise. 0.68. What is the ratio of the Electricity production(% of total) in Latvia in 2001 to that in 2007?
Make the answer very short. 0.76. What is the ratio of the Electricity production(% of total) of Saudi Arabia in 2001 to that in 2007?
Offer a very short reply. 1.04. What is the ratio of the Electricity production(% of total) of Italy in 2002 to that in 2003?
Give a very brief answer. 0.87. What is the ratio of the Electricity production(% of total) of Latvia in 2002 to that in 2003?
Provide a short and direct response. 0.86. What is the ratio of the Electricity production(% of total) of Saudi Arabia in 2002 to that in 2003?
Provide a short and direct response. 1.02. What is the ratio of the Electricity production(% of total) in Indonesia in 2002 to that in 2004?
Give a very brief answer. 1.35. What is the ratio of the Electricity production(% of total) of Italy in 2002 to that in 2004?
Make the answer very short. 0.82. What is the ratio of the Electricity production(% of total) in Latvia in 2002 to that in 2004?
Provide a succinct answer. 1.08. What is the ratio of the Electricity production(% of total) in Saudi Arabia in 2002 to that in 2004?
Offer a terse response. 0.98. What is the ratio of the Electricity production(% of total) in Indonesia in 2002 to that in 2005?
Give a very brief answer. 1.45. What is the ratio of the Electricity production(% of total) of Italy in 2002 to that in 2005?
Your answer should be very brief. 0.71. What is the ratio of the Electricity production(% of total) in Latvia in 2002 to that in 2005?
Your response must be concise. 1.09. What is the ratio of the Electricity production(% of total) in Saudi Arabia in 2002 to that in 2005?
Provide a succinct answer. 0.99. What is the ratio of the Electricity production(% of total) of Indonesia in 2002 to that in 2006?
Your answer should be very brief. 1.46. What is the ratio of the Electricity production(% of total) in Italy in 2002 to that in 2006?
Give a very brief answer. 0.7. What is the ratio of the Electricity production(% of total) of Latvia in 2002 to that in 2006?
Keep it short and to the point. 0.77. What is the ratio of the Electricity production(% of total) of Saudi Arabia in 2002 to that in 2006?
Provide a short and direct response. 1.05. What is the ratio of the Electricity production(% of total) of Indonesia in 2002 to that in 2007?
Offer a very short reply. 1.34. What is the ratio of the Electricity production(% of total) of Italy in 2002 to that in 2007?
Provide a short and direct response. 0.64. What is the ratio of the Electricity production(% of total) of Latvia in 2002 to that in 2007?
Offer a very short reply. 0.82. What is the ratio of the Electricity production(% of total) in Saudi Arabia in 2002 to that in 2007?
Make the answer very short. 1.11. What is the ratio of the Electricity production(% of total) of Indonesia in 2003 to that in 2004?
Make the answer very short. 1.31. What is the ratio of the Electricity production(% of total) of Italy in 2003 to that in 2004?
Offer a very short reply. 0.93. What is the ratio of the Electricity production(% of total) in Latvia in 2003 to that in 2004?
Keep it short and to the point. 1.26. What is the ratio of the Electricity production(% of total) of Saudi Arabia in 2003 to that in 2004?
Offer a terse response. 0.96. What is the ratio of the Electricity production(% of total) of Indonesia in 2003 to that in 2005?
Your answer should be very brief. 1.4. What is the ratio of the Electricity production(% of total) of Italy in 2003 to that in 2005?
Ensure brevity in your answer.  0.81. What is the ratio of the Electricity production(% of total) of Latvia in 2003 to that in 2005?
Ensure brevity in your answer.  1.27. What is the ratio of the Electricity production(% of total) in Saudi Arabia in 2003 to that in 2005?
Give a very brief answer. 0.97. What is the ratio of the Electricity production(% of total) of Indonesia in 2003 to that in 2006?
Your answer should be very brief. 1.41. What is the ratio of the Electricity production(% of total) in Italy in 2003 to that in 2006?
Make the answer very short. 0.8. What is the ratio of the Electricity production(% of total) in Latvia in 2003 to that in 2006?
Provide a succinct answer. 0.9. What is the ratio of the Electricity production(% of total) in Saudi Arabia in 2003 to that in 2006?
Your answer should be compact. 1.03. What is the ratio of the Electricity production(% of total) of Indonesia in 2003 to that in 2007?
Offer a very short reply. 1.3. What is the ratio of the Electricity production(% of total) in Italy in 2003 to that in 2007?
Your answer should be very brief. 0.73. What is the ratio of the Electricity production(% of total) of Latvia in 2003 to that in 2007?
Give a very brief answer. 0.96. What is the ratio of the Electricity production(% of total) of Saudi Arabia in 2003 to that in 2007?
Provide a succinct answer. 1.09. What is the ratio of the Electricity production(% of total) in Indonesia in 2004 to that in 2005?
Your answer should be compact. 1.07. What is the ratio of the Electricity production(% of total) in Italy in 2004 to that in 2005?
Make the answer very short. 0.87. What is the ratio of the Electricity production(% of total) in Latvia in 2004 to that in 2005?
Provide a short and direct response. 1.01. What is the ratio of the Electricity production(% of total) of Saudi Arabia in 2004 to that in 2005?
Keep it short and to the point. 1.01. What is the ratio of the Electricity production(% of total) in Indonesia in 2004 to that in 2006?
Offer a terse response. 1.08. What is the ratio of the Electricity production(% of total) of Italy in 2004 to that in 2006?
Offer a terse response. 0.85. What is the ratio of the Electricity production(% of total) of Latvia in 2004 to that in 2006?
Give a very brief answer. 0.71. What is the ratio of the Electricity production(% of total) in Saudi Arabia in 2004 to that in 2006?
Ensure brevity in your answer.  1.07. What is the ratio of the Electricity production(% of total) in Italy in 2004 to that in 2007?
Your response must be concise. 0.78. What is the ratio of the Electricity production(% of total) of Latvia in 2004 to that in 2007?
Your answer should be compact. 0.76. What is the ratio of the Electricity production(% of total) of Saudi Arabia in 2004 to that in 2007?
Give a very brief answer. 1.13. What is the ratio of the Electricity production(% of total) of Indonesia in 2005 to that in 2006?
Provide a short and direct response. 1.01. What is the ratio of the Electricity production(% of total) of Italy in 2005 to that in 2006?
Provide a short and direct response. 0.98. What is the ratio of the Electricity production(% of total) in Latvia in 2005 to that in 2006?
Offer a terse response. 0.71. What is the ratio of the Electricity production(% of total) of Saudi Arabia in 2005 to that in 2006?
Make the answer very short. 1.06. What is the ratio of the Electricity production(% of total) of Indonesia in 2005 to that in 2007?
Keep it short and to the point. 0.93. What is the ratio of the Electricity production(% of total) in Italy in 2005 to that in 2007?
Your answer should be very brief. 0.9. What is the ratio of the Electricity production(% of total) in Latvia in 2005 to that in 2007?
Your answer should be compact. 0.75. What is the ratio of the Electricity production(% of total) of Saudi Arabia in 2005 to that in 2007?
Ensure brevity in your answer.  1.12. What is the ratio of the Electricity production(% of total) in Indonesia in 2006 to that in 2007?
Provide a short and direct response. 0.92. What is the ratio of the Electricity production(% of total) of Italy in 2006 to that in 2007?
Provide a succinct answer. 0.92. What is the ratio of the Electricity production(% of total) in Latvia in 2006 to that in 2007?
Keep it short and to the point. 1.06. What is the ratio of the Electricity production(% of total) in Saudi Arabia in 2006 to that in 2007?
Your answer should be compact. 1.06. What is the difference between the highest and the second highest Electricity production(% of total) in Indonesia?
Your response must be concise. 3.86. What is the difference between the highest and the second highest Electricity production(% of total) in Italy?
Ensure brevity in your answer.  4.64. What is the difference between the highest and the second highest Electricity production(% of total) in Latvia?
Offer a very short reply. 2.59. What is the difference between the highest and the second highest Electricity production(% of total) in Saudi Arabia?
Offer a terse response. 0.45. What is the difference between the highest and the lowest Electricity production(% of total) in Indonesia?
Keep it short and to the point. 10.82. What is the difference between the highest and the lowest Electricity production(% of total) in Italy?
Provide a succinct answer. 20.19. What is the difference between the highest and the lowest Electricity production(% of total) in Latvia?
Ensure brevity in your answer.  12.65. What is the difference between the highest and the lowest Electricity production(% of total) in Saudi Arabia?
Offer a terse response. 6.7. 